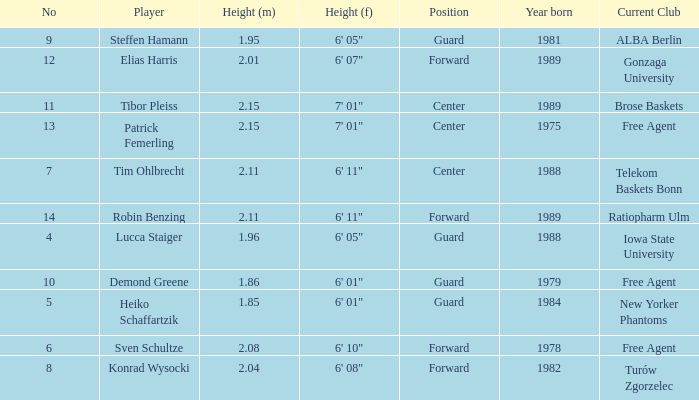Name the height for the player born 1989 and height 2.11 6' 11". 